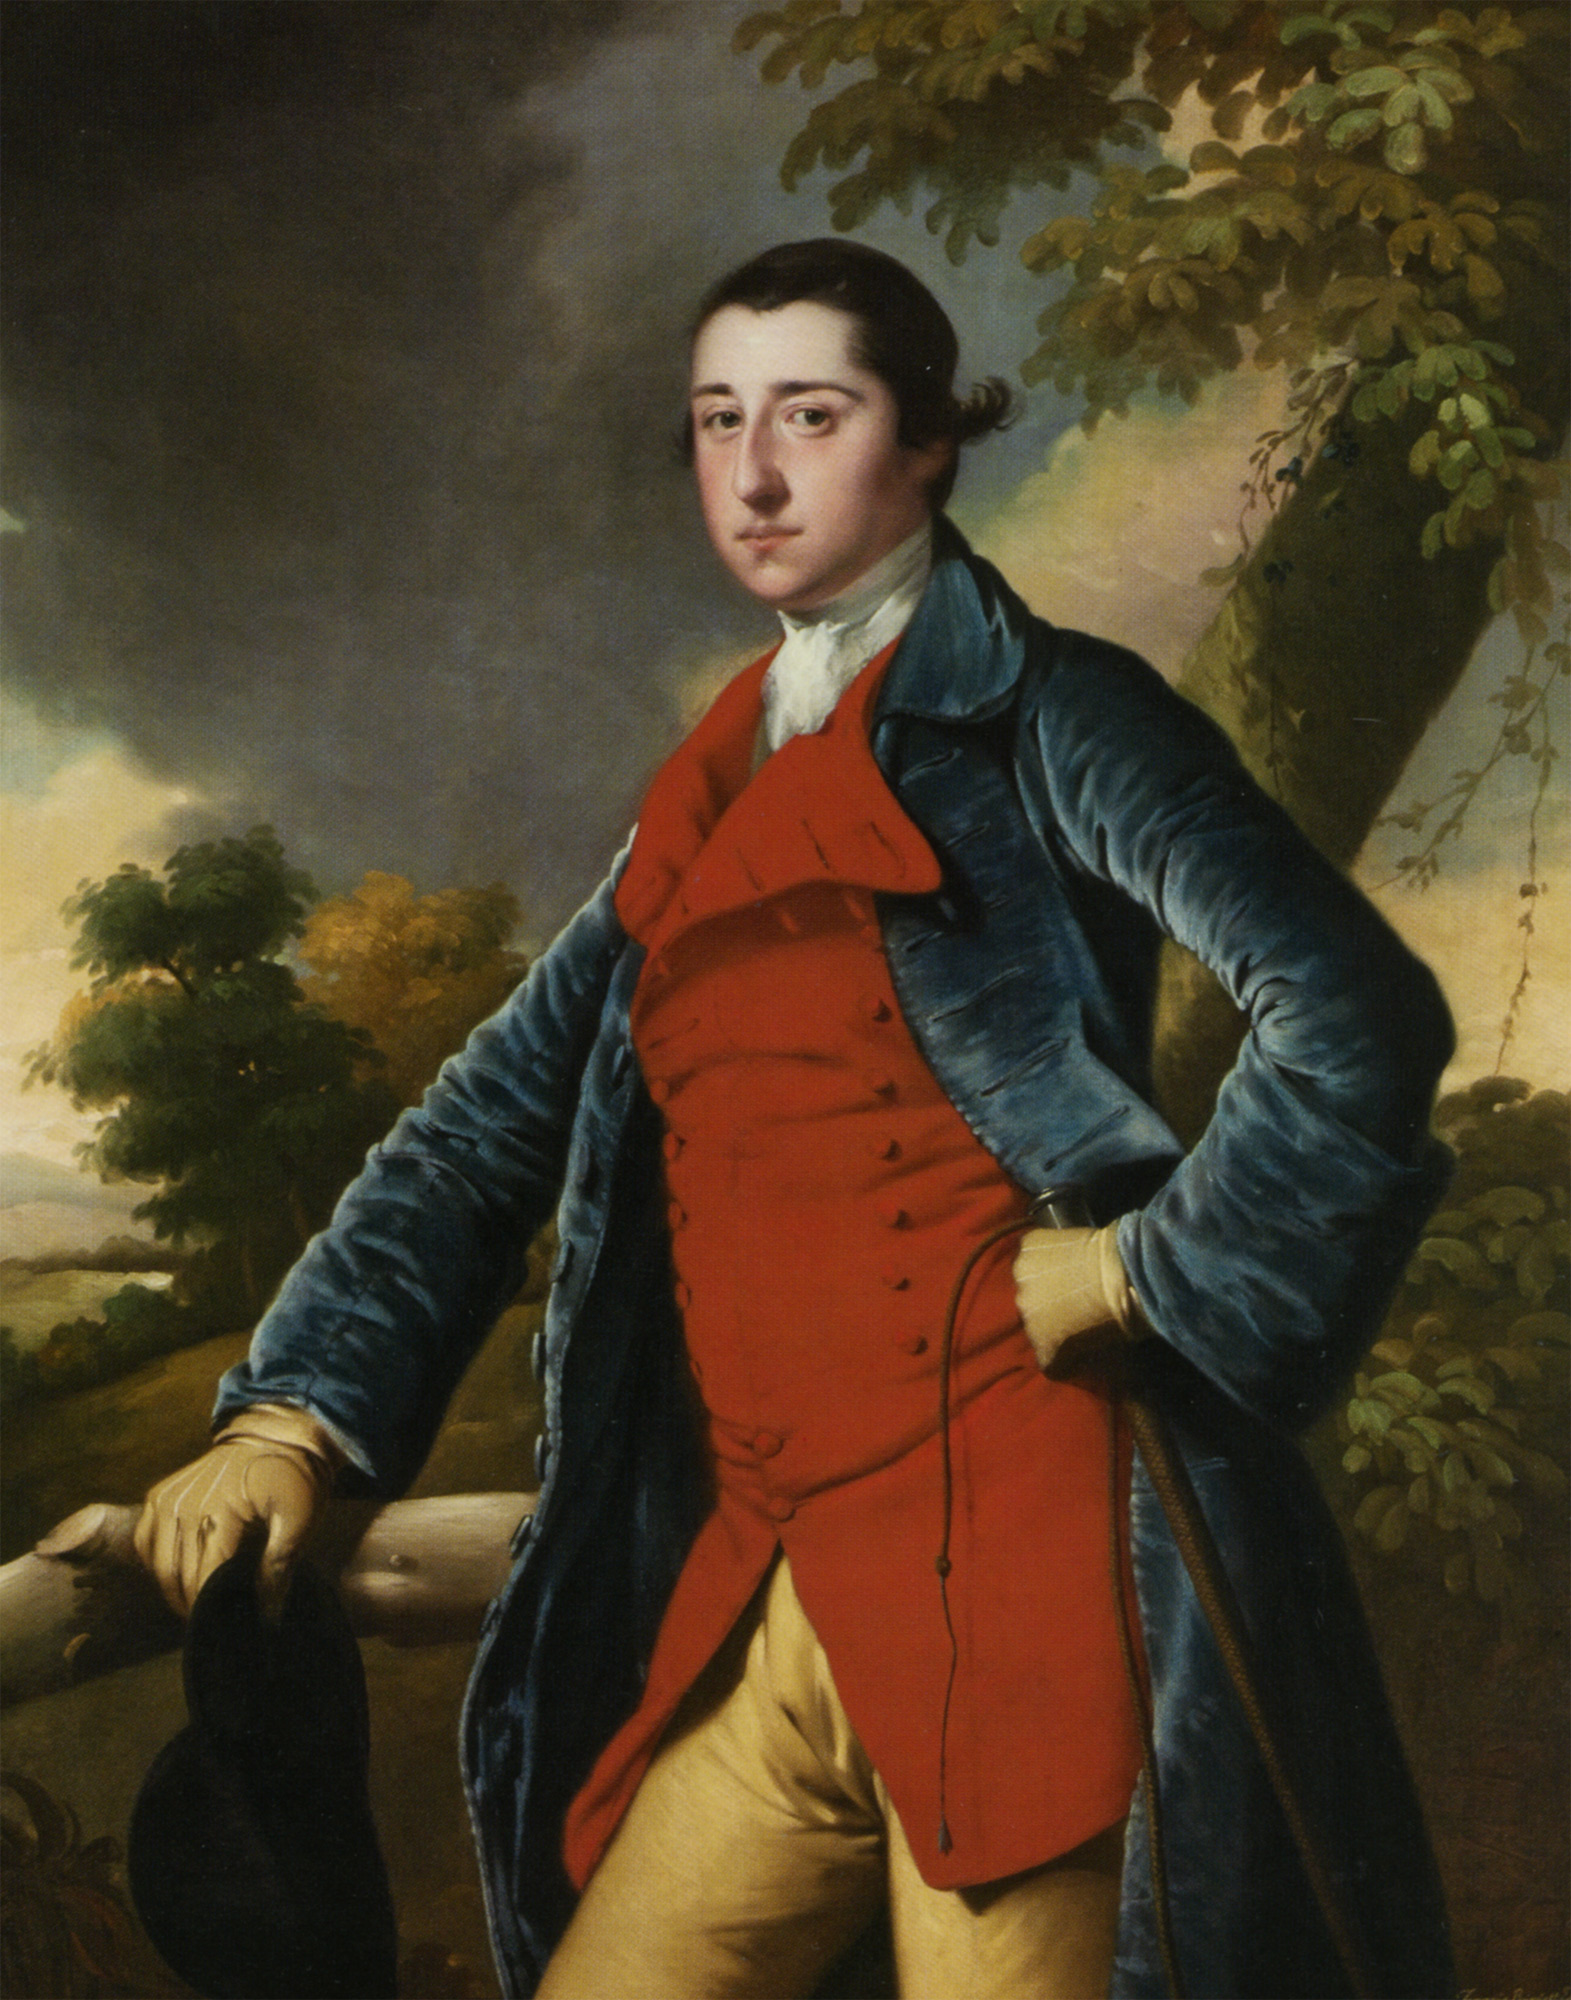What can you say about the fashion in the image and its significance during the 18th century? The fashion depicted in the image highlights the elegance and sophistication of the 18th century. The man's outfit, consisting of a blue coat with gold buttons, a red waistcoat, and yellow breeches, reflects the style common among the aristocracy and influential figures of the period. The colors and materials suggest wealth and status, and the tailored fit emphasizes a refined appearance. This style was partly influenced by the Rococo movement, known for lightness and elaborate ornamentation. Accessories, such as the black hat, were also significant, adding an element of prestige and formality to the ensemble. 